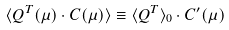<formula> <loc_0><loc_0><loc_500><loc_500>\langle Q ^ { T } ( \mu ) \cdot C ( \mu ) \rangle \equiv \langle Q ^ { T } \rangle _ { 0 } \cdot C ^ { \prime } ( \mu )</formula> 